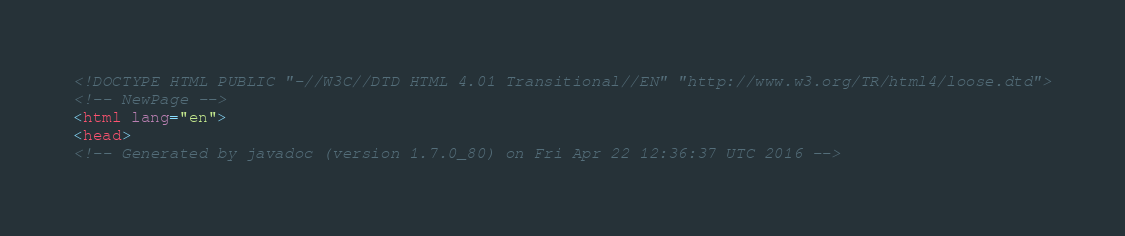<code> <loc_0><loc_0><loc_500><loc_500><_HTML_><!DOCTYPE HTML PUBLIC "-//W3C//DTD HTML 4.01 Transitional//EN" "http://www.w3.org/TR/html4/loose.dtd">
<!-- NewPage -->
<html lang="en">
<head>
<!-- Generated by javadoc (version 1.7.0_80) on Fri Apr 22 12:36:37 UTC 2016 --></code> 